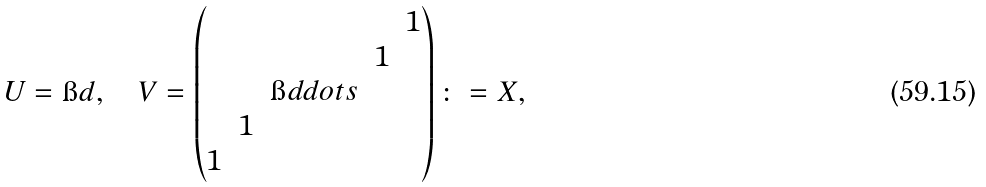Convert formula to latex. <formula><loc_0><loc_0><loc_500><loc_500>U = \i d , \quad V = \begin{pmatrix} & & & & 1 \\ & & & 1 \\ & & \i d d o t s \\ & 1 \\ 1 \end{pmatrix} \colon = X ,</formula> 